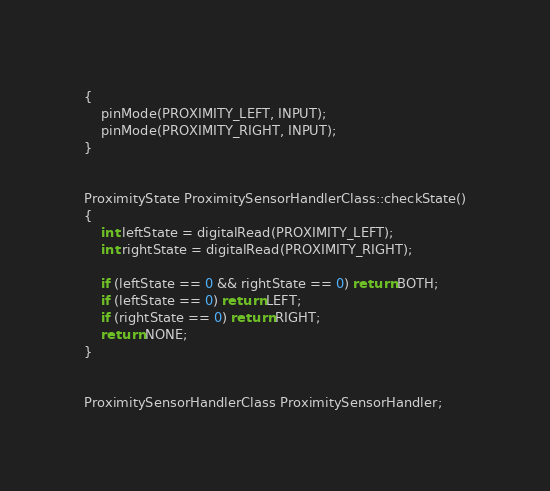<code> <loc_0><loc_0><loc_500><loc_500><_C++_>{
	pinMode(PROXIMITY_LEFT, INPUT);
	pinMode(PROXIMITY_RIGHT, INPUT);
}


ProximityState ProximitySensorHandlerClass::checkState()
{
	int leftState = digitalRead(PROXIMITY_LEFT);
	int rightState = digitalRead(PROXIMITY_RIGHT);

	if (leftState == 0 && rightState == 0) return BOTH;
	if (leftState == 0) return LEFT;
	if (rightState == 0) return RIGHT;
	return NONE;
}


ProximitySensorHandlerClass ProximitySensorHandler;

</code> 